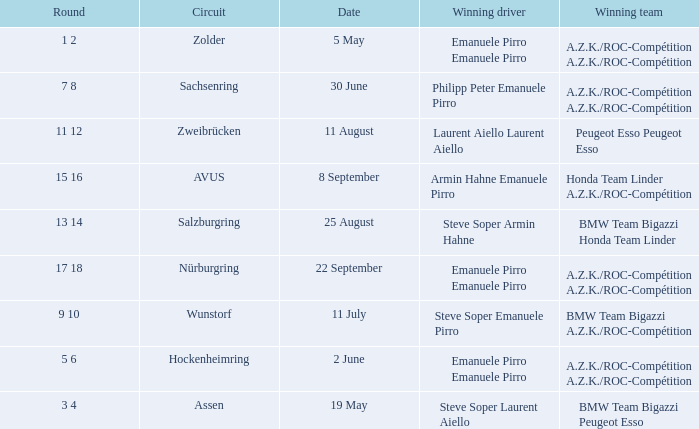Who is the winning driver of the race on 2 June with a.z.k./roc-compétition a.z.k./roc-compétition as the winning team? Emanuele Pirro Emanuele Pirro. 